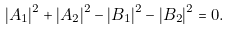Convert formula to latex. <formula><loc_0><loc_0><loc_500><loc_500>| A _ { 1 } | ^ { 2 } + | A _ { 2 } | ^ { 2 } - | B _ { 1 } | ^ { 2 } - | B _ { 2 } | ^ { 2 } = 0 .</formula> 